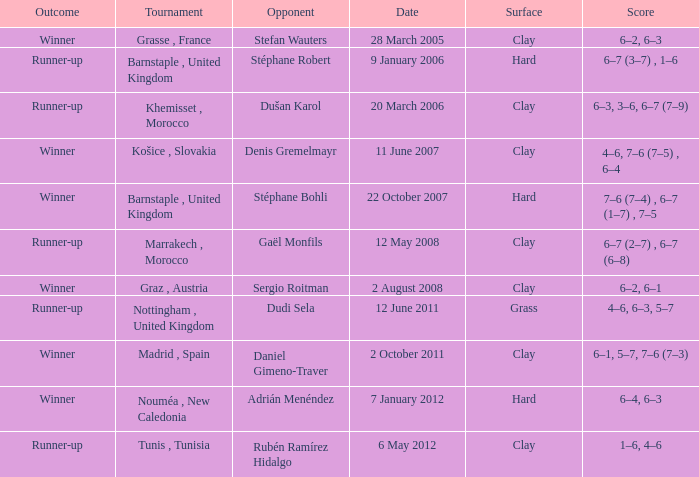What is the surface of the tournament with a runner-up outcome and dudi sela as the opponent? Grass. Could you parse the entire table as a dict? {'header': ['Outcome', 'Tournament', 'Opponent', 'Date', 'Surface', 'Score'], 'rows': [['Winner', 'Grasse , France', 'Stefan Wauters', '28 March 2005', 'Clay', '6–2, 6–3'], ['Runner-up', 'Barnstaple , United Kingdom', 'Stéphane Robert', '9 January 2006', 'Hard', '6–7 (3–7) , 1–6'], ['Runner-up', 'Khemisset , Morocco', 'Dušan Karol', '20 March 2006', 'Clay', '6–3, 3–6, 6–7 (7–9)'], ['Winner', 'Košice , Slovakia', 'Denis Gremelmayr', '11 June 2007', 'Clay', '4–6, 7–6 (7–5) , 6–4'], ['Winner', 'Barnstaple , United Kingdom', 'Stéphane Bohli', '22 October 2007', 'Hard', '7–6 (7–4) , 6–7 (1–7) , 7–5'], ['Runner-up', 'Marrakech , Morocco', 'Gaël Monfils', '12 May 2008', 'Clay', '6–7 (2–7) , 6–7 (6–8)'], ['Winner', 'Graz , Austria', 'Sergio Roitman', '2 August 2008', 'Clay', '6–2, 6–1'], ['Runner-up', 'Nottingham , United Kingdom', 'Dudi Sela', '12 June 2011', 'Grass', '4–6, 6–3, 5–7'], ['Winner', 'Madrid , Spain', 'Daniel Gimeno-Traver', '2 October 2011', 'Clay', '6–1, 5–7, 7–6 (7–3)'], ['Winner', 'Nouméa , New Caledonia', 'Adrián Menéndez', '7 January 2012', 'Hard', '6–4, 6–3'], ['Runner-up', 'Tunis , Tunisia', 'Rubén Ramírez Hidalgo', '6 May 2012', 'Clay', '1–6, 4–6']]} 